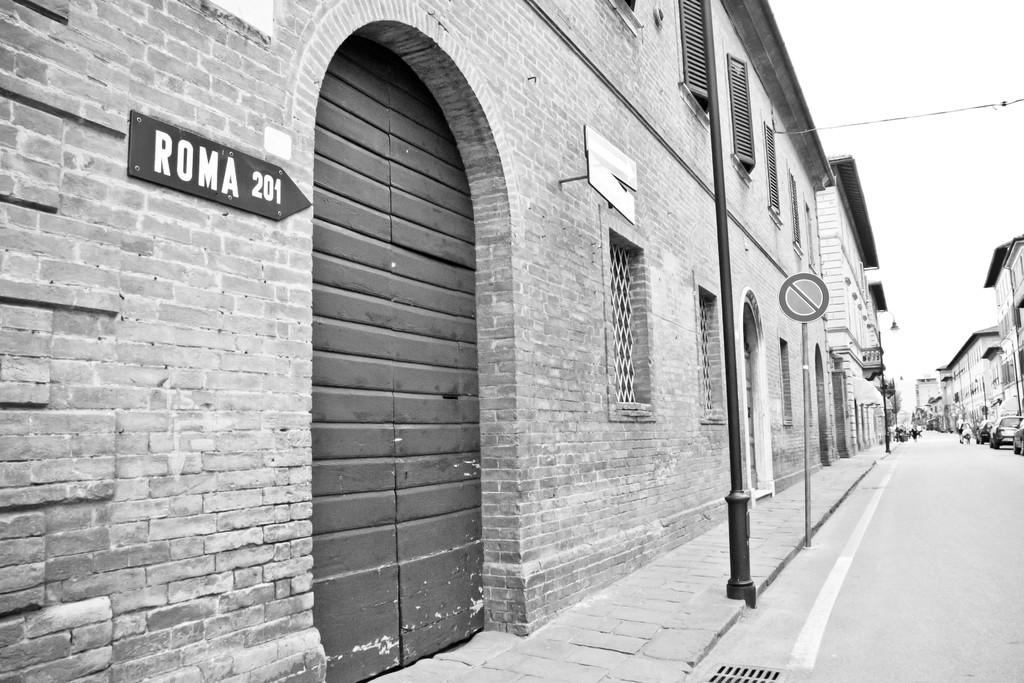What is the color scheme of the image? The image is black and white. What type of structures can be seen in the image? There are buildings in the image. Can you identify any specific architectural features? Yes, there is a door and windows visible in the image. What else can be seen in the image besides buildings? There are poles, a footpath, cars, and a road on the right side of the image. How many babies are present in the image, and what advice are they giving? There are no babies present in the image, and therefore no advice can be given. What type of books can be seen on the shelves in the image? There are no shelves or books visible in the image. 